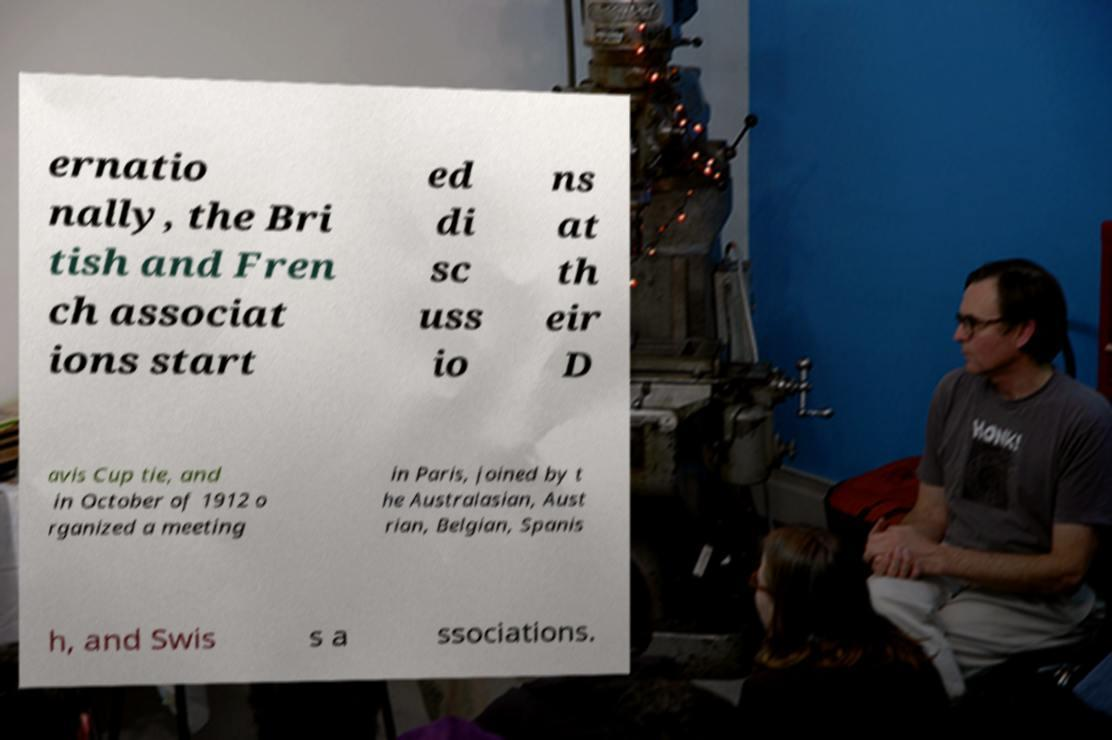Could you assist in decoding the text presented in this image and type it out clearly? ernatio nally, the Bri tish and Fren ch associat ions start ed di sc uss io ns at th eir D avis Cup tie, and in October of 1912 o rganized a meeting in Paris, joined by t he Australasian, Aust rian, Belgian, Spanis h, and Swis s a ssociations. 